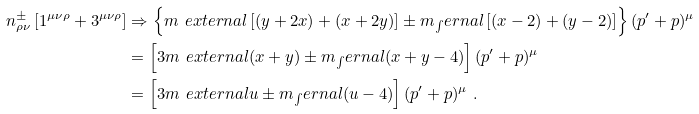Convert formula to latex. <formula><loc_0><loc_0><loc_500><loc_500>n _ { \rho \nu } ^ { \pm } \left [ 1 ^ { \mu \nu \rho } + 3 ^ { \mu \nu \rho } \right ] & \Rightarrow \left \{ m _ { \ } e x t e r n a l \left [ ( y + 2 x ) + ( x + 2 y ) \right ] \pm m _ { \int } e r n a l \left [ ( x - 2 ) + ( y - 2 ) \right ] \right \} ( p ^ { \prime } + p ) ^ { \mu } \\ & = \left [ 3 m _ { \ } e x t e r n a l ( x + y ) \pm m _ { \int } e r n a l ( x + y - 4 ) \right ] ( p ^ { \prime } + p ) ^ { \mu } \\ & = \left [ 3 m _ { \ } e x t e r n a l u \pm m _ { \int } e r n a l ( u - 4 ) \right ] ( p ^ { \prime } + p ) ^ { \mu } \ .</formula> 